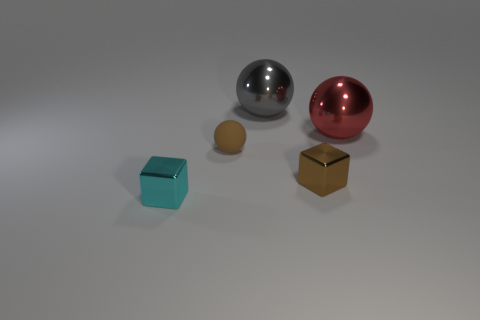Is there anything else that has the same material as the brown ball?
Ensure brevity in your answer.  No. There is a brown object that is on the left side of the tiny metal thing behind the small cyan metal object; are there any shiny blocks behind it?
Offer a very short reply. No. There is another thing that is the same shape as the small cyan metallic object; what material is it?
Offer a very short reply. Metal. Is the small ball made of the same material as the tiny block left of the brown matte ball?
Give a very brief answer. No. What is the shape of the tiny shiny object that is behind the cube that is on the left side of the brown rubber object?
Offer a terse response. Cube. What number of large things are rubber spheres or metallic blocks?
Offer a very short reply. 0. What number of tiny brown things have the same shape as the big red thing?
Make the answer very short. 1. There is a large red object; is it the same shape as the shiny thing behind the red ball?
Offer a very short reply. Yes. How many blocks are on the right side of the small brown matte thing?
Your response must be concise. 1. Are there any red metal spheres of the same size as the gray metal object?
Keep it short and to the point. Yes. 